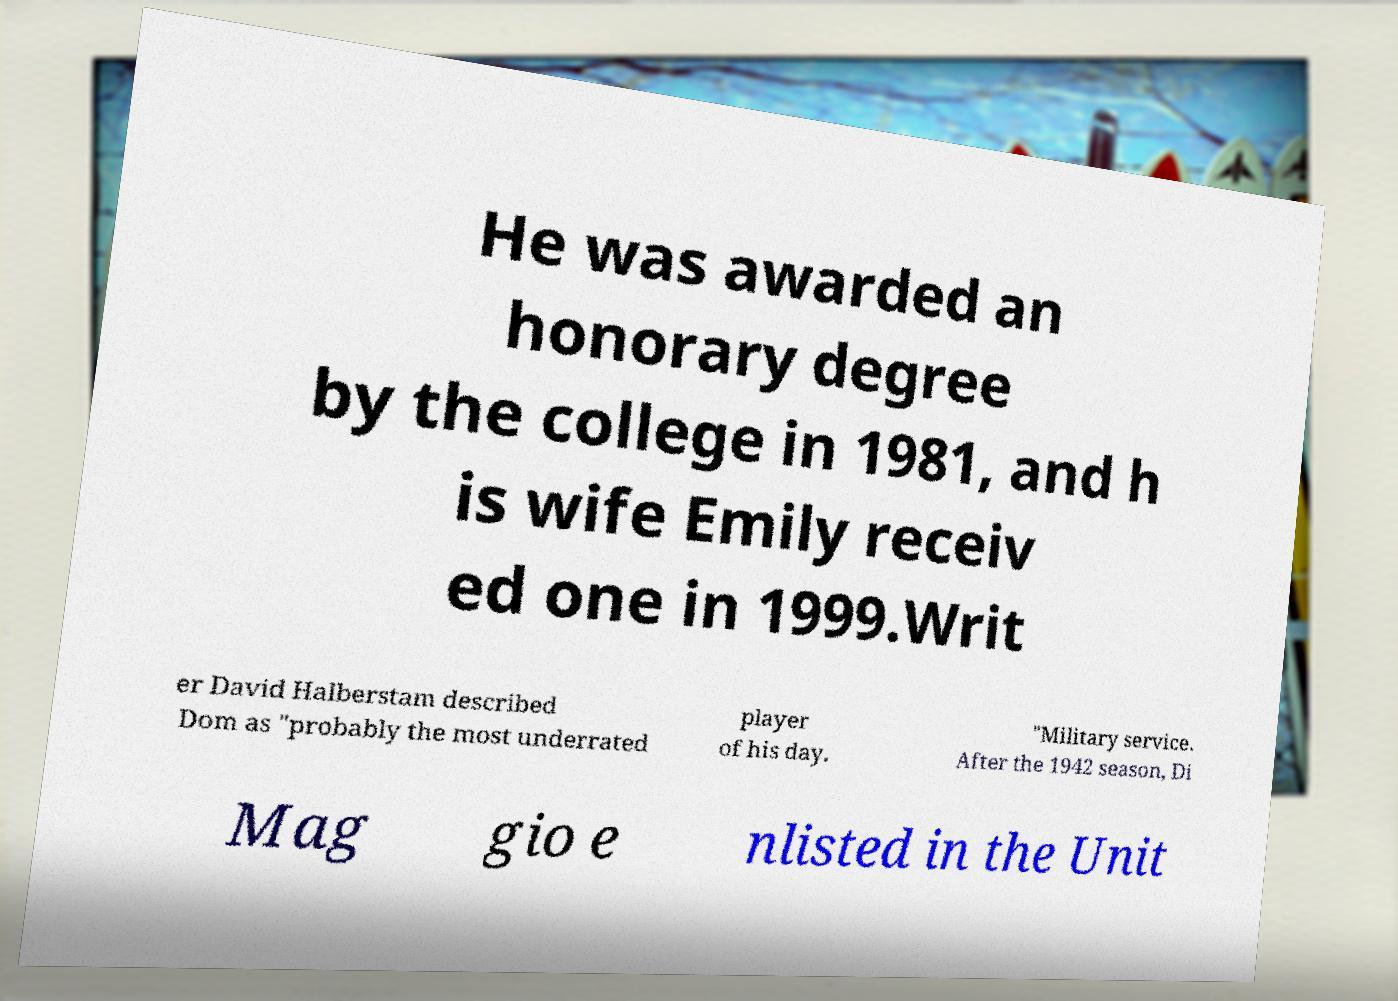Could you extract and type out the text from this image? He was awarded an honorary degree by the college in 1981, and h is wife Emily receiv ed one in 1999.Writ er David Halberstam described Dom as "probably the most underrated player of his day. "Military service. After the 1942 season, Di Mag gio e nlisted in the Unit 